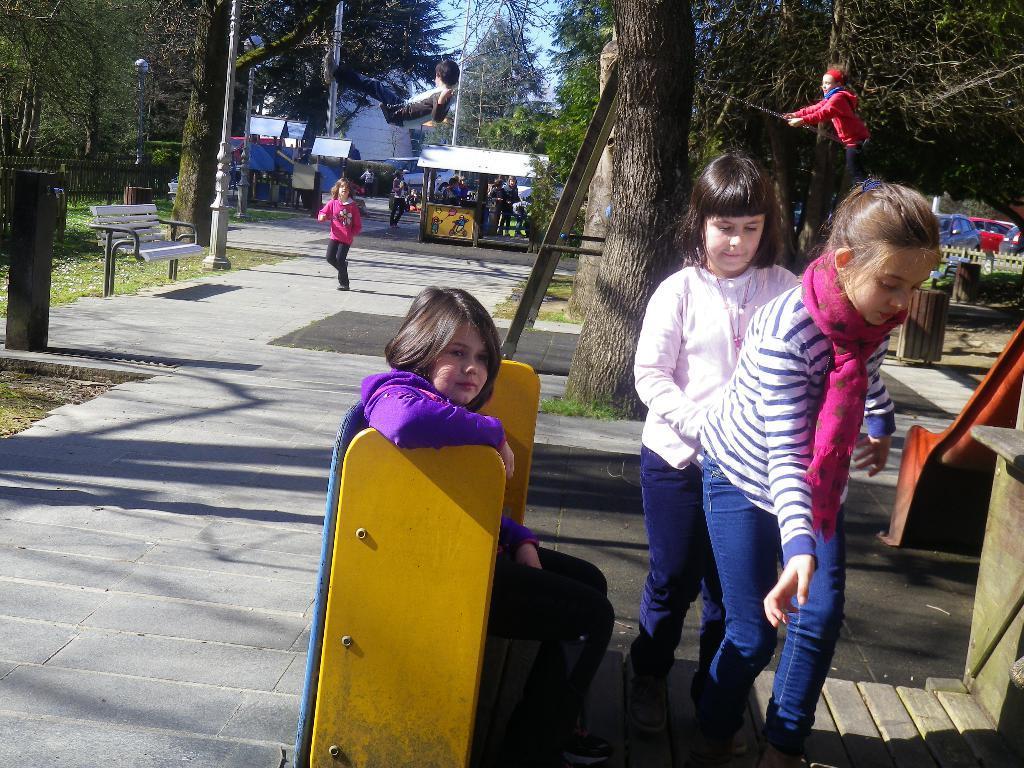In one or two sentences, can you explain what this image depicts? In this image we can see two girls are standing and one girl is sitting on the yellow color thing. There is a slide ride on the right side of the image. In the background, we can see trees, poles, stalls, bench, grassy land, fencing, cars and children are playing. 